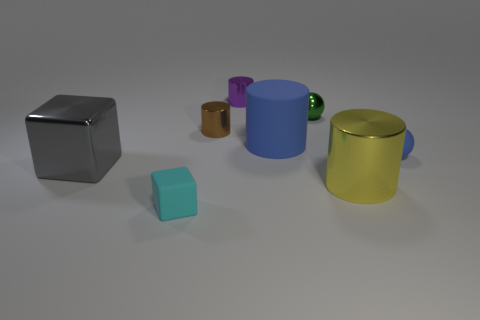Add 1 green things. How many objects exist? 9 Subtract all gray cylinders. Subtract all yellow blocks. How many cylinders are left? 4 Subtract all blocks. How many objects are left? 6 Subtract all big rubber cylinders. Subtract all tiny shiny balls. How many objects are left? 6 Add 4 tiny green spheres. How many tiny green spheres are left? 5 Add 3 big green objects. How many big green objects exist? 3 Subtract 0 red blocks. How many objects are left? 8 